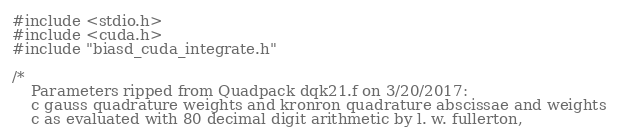Convert code to text. <code><loc_0><loc_0><loc_500><loc_500><_Cuda_>#include <stdio.h>
#include <cuda.h>
#include "biasd_cuda_integrate.h"

/*
	Parameters ripped from Quadpack dqk21.f on 3/20/2017:
	c gauss quadrature weights and kronron quadrature abscissae and weights
	c as evaluated with 80 decimal digit arithmetic by l. w. fullerton,</code> 